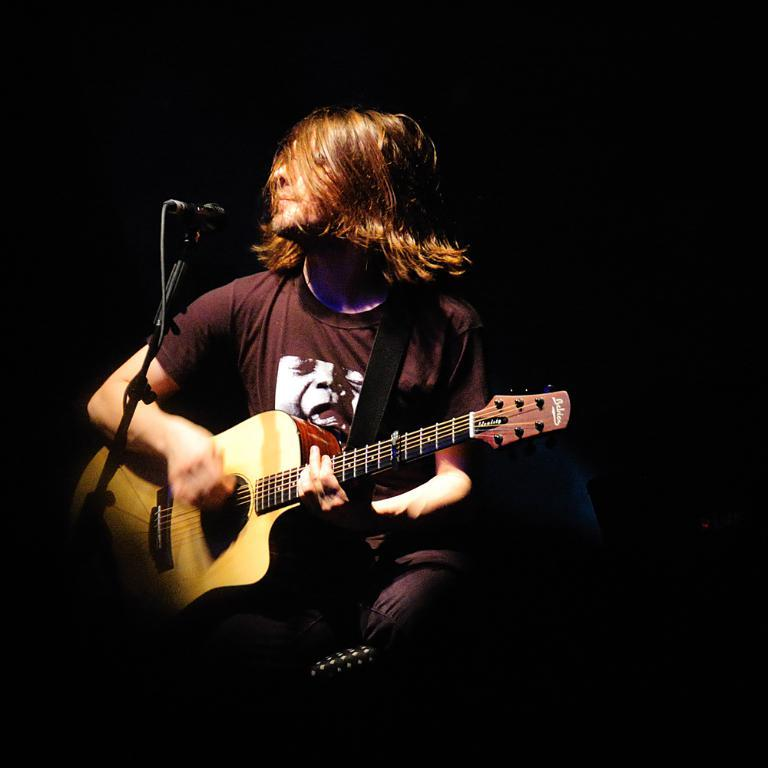What is the man in the image doing? The man is playing a guitar. What is the man wearing in the image? The man is wearing a maroon t-shirt. What object is in front of the man? There is a microphone in front of the man. How would you describe the background of the image? The background of the image is dark. Reasoning: Let'g: Let's think step by step in order to produce the conversation. We start by identifying the main subject in the image, which is the man. Then, we describe what the man is doing, which is playing a guitar. Next, we mention what the man is wearing, which is a maroon t-shirt. We also include the presence of a microphone in front of the man. Finally, we describe the background of the image, which is dark. Absurd Question/Answer: How many rabbits can be seen in the image? There are no rabbits present in the image. What type of art is displayed on the wall behind the man? There is no art displayed on the wall behind the man in the image. 